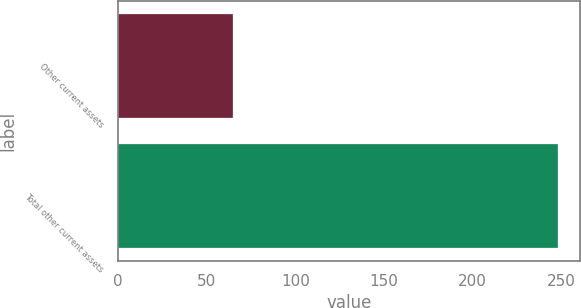Convert chart. <chart><loc_0><loc_0><loc_500><loc_500><bar_chart><fcel>Other current assets<fcel>Total other current assets<nl><fcel>65<fcel>248<nl></chart> 